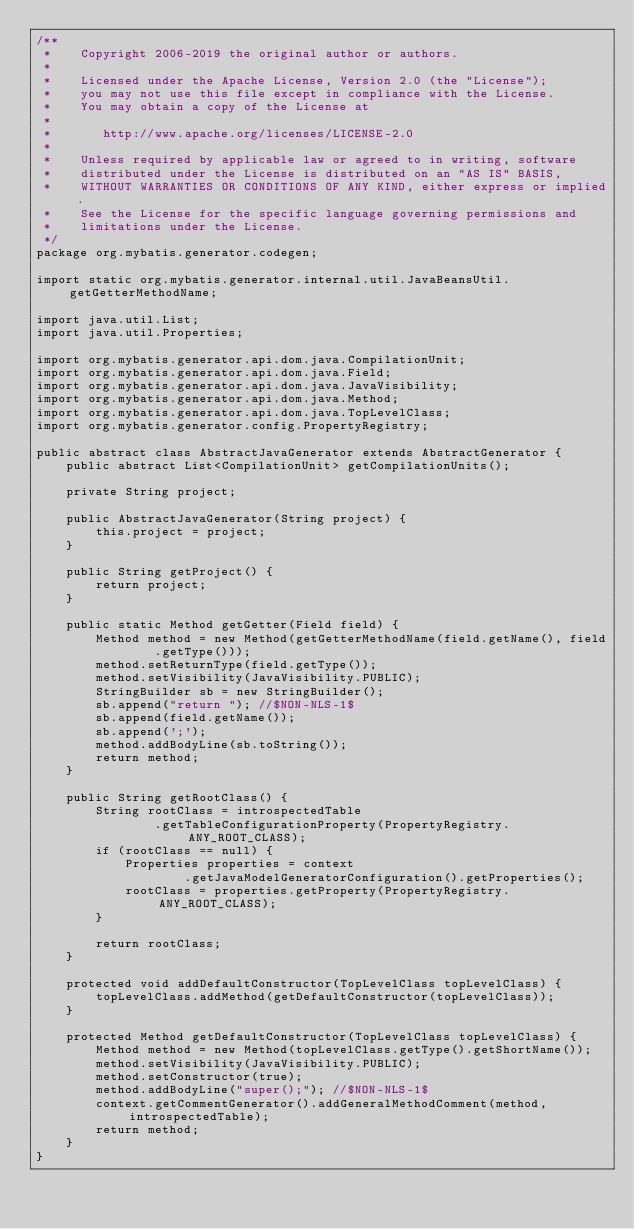Convert code to text. <code><loc_0><loc_0><loc_500><loc_500><_Java_>/**
 *    Copyright 2006-2019 the original author or authors.
 *
 *    Licensed under the Apache License, Version 2.0 (the "License");
 *    you may not use this file except in compliance with the License.
 *    You may obtain a copy of the License at
 *
 *       http://www.apache.org/licenses/LICENSE-2.0
 *
 *    Unless required by applicable law or agreed to in writing, software
 *    distributed under the License is distributed on an "AS IS" BASIS,
 *    WITHOUT WARRANTIES OR CONDITIONS OF ANY KIND, either express or implied.
 *    See the License for the specific language governing permissions and
 *    limitations under the License.
 */
package org.mybatis.generator.codegen;

import static org.mybatis.generator.internal.util.JavaBeansUtil.getGetterMethodName;

import java.util.List;
import java.util.Properties;

import org.mybatis.generator.api.dom.java.CompilationUnit;
import org.mybatis.generator.api.dom.java.Field;
import org.mybatis.generator.api.dom.java.JavaVisibility;
import org.mybatis.generator.api.dom.java.Method;
import org.mybatis.generator.api.dom.java.TopLevelClass;
import org.mybatis.generator.config.PropertyRegistry;

public abstract class AbstractJavaGenerator extends AbstractGenerator {
    public abstract List<CompilationUnit> getCompilationUnits();
    
    private String project;
    
    public AbstractJavaGenerator(String project) {
        this.project = project;
    }
    
    public String getProject() {
        return project;
    }

    public static Method getGetter(Field field) {
        Method method = new Method(getGetterMethodName(field.getName(), field
                .getType()));
        method.setReturnType(field.getType());
        method.setVisibility(JavaVisibility.PUBLIC);
        StringBuilder sb = new StringBuilder();
        sb.append("return "); //$NON-NLS-1$
        sb.append(field.getName());
        sb.append(';');
        method.addBodyLine(sb.toString());
        return method;
    }

    public String getRootClass() {
        String rootClass = introspectedTable
                .getTableConfigurationProperty(PropertyRegistry.ANY_ROOT_CLASS);
        if (rootClass == null) {
            Properties properties = context
                    .getJavaModelGeneratorConfiguration().getProperties();
            rootClass = properties.getProperty(PropertyRegistry.ANY_ROOT_CLASS);
        }

        return rootClass;
    }

    protected void addDefaultConstructor(TopLevelClass topLevelClass) {
        topLevelClass.addMethod(getDefaultConstructor(topLevelClass));
    }

    protected Method getDefaultConstructor(TopLevelClass topLevelClass) {
        Method method = new Method(topLevelClass.getType().getShortName());
        method.setVisibility(JavaVisibility.PUBLIC);
        method.setConstructor(true);
        method.addBodyLine("super();"); //$NON-NLS-1$
        context.getCommentGenerator().addGeneralMethodComment(method, introspectedTable);
        return method;
    }
}
</code> 